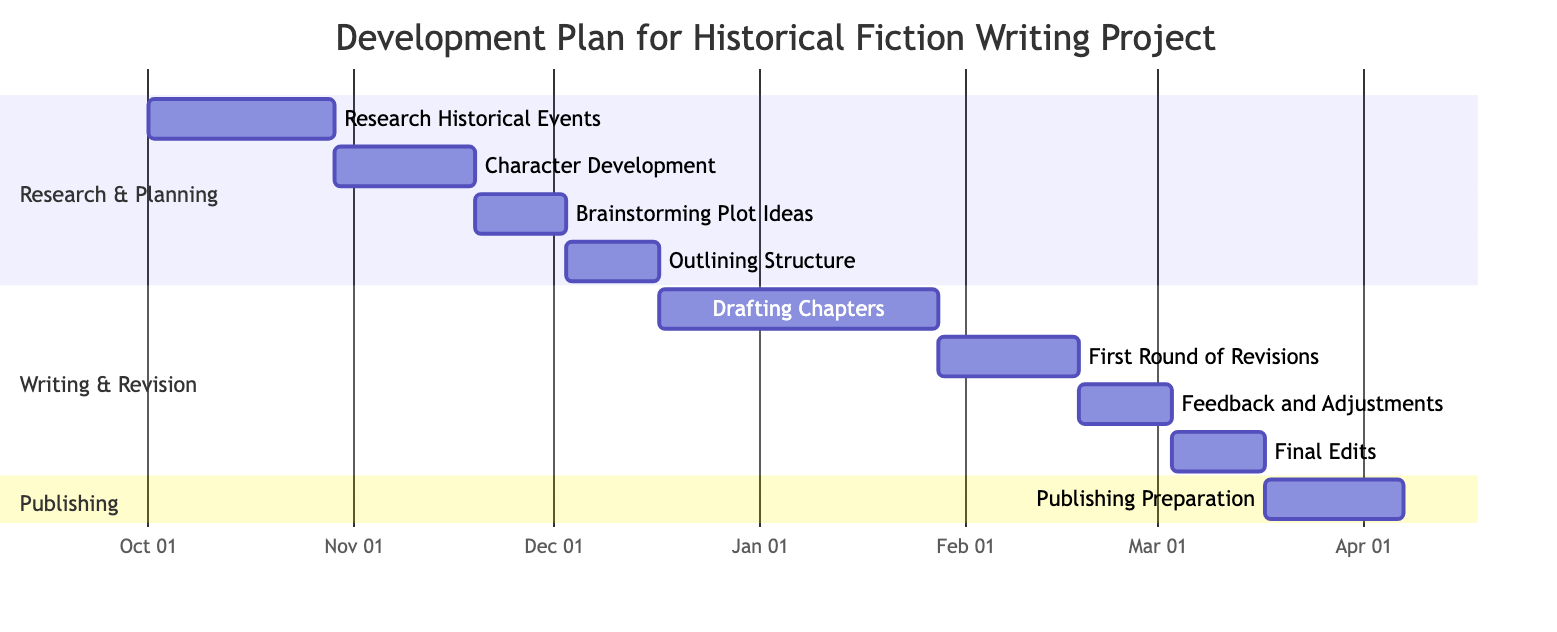What is the duration of the "Research Historical Events" phase? The diagram states that the "Research Historical Events" phase has a duration of "4 weeks." This can be found by looking at the specific entry for this phase in the chart, which clearly lists the duration.
Answer: 4 weeks When does the "Character Development" phase start? The "Character Development" phase begins on "2023-10-29," as indicated in the diagram. This date is marked next to the corresponding phase entry.
Answer: 2023-10-29 How many weeks is the total duration for the writing and revision phases combined? The writing and revision phases consist of "Drafting Chapters" (6 weeks), "First Round of Revisions" (3 weeks), "Feedback and Adjustments" (2 weeks), and "Final Edits" (2 weeks). Adding these durations gives a total of 6 + 3 + 2 + 2 = 13 weeks.
Answer: 13 weeks Which phase has its endpoint just before the start of "Drafting Chapters"? The phase that ends just before "Drafting Chapters" is "Outlining Structure," which concludes on "2023-12-16." This can be found by checking the end dates of the phases leading up to "Drafting Chapters."
Answer: Outlining Structure What are the last two phases in the development plan? The last two phases in the development plan are "Final Edits" and "Publishing Preparation." These can be identified as they are positioned at the bottom of the diagram, following the other phases in order.
Answer: Final Edits and Publishing Preparation How long does the "Feedback and Adjustments" phase last? The "Feedback and Adjustments" phase lasts for "2 weeks," as can be seen in the duration section of this phase in the chart.
Answer: 2 weeks Which section does "Brainstorming Plot Ideas" belong to? The "Brainstorming Plot Ideas" phase is part of the "Research & Planning" section. This information is directly visible in the labeled sections of the Gantt chart.
Answer: Research & Planning What is the time span from the start of the writing phase to the end of the final edits? The writing phase starts on "2023-12-17" and the final edits end on "2024-03-16." To calculate the time span, we can determine the number of weeks from the start to the end date, which is approximately 12 weeks or 3 months.
Answer: 12 weeks 